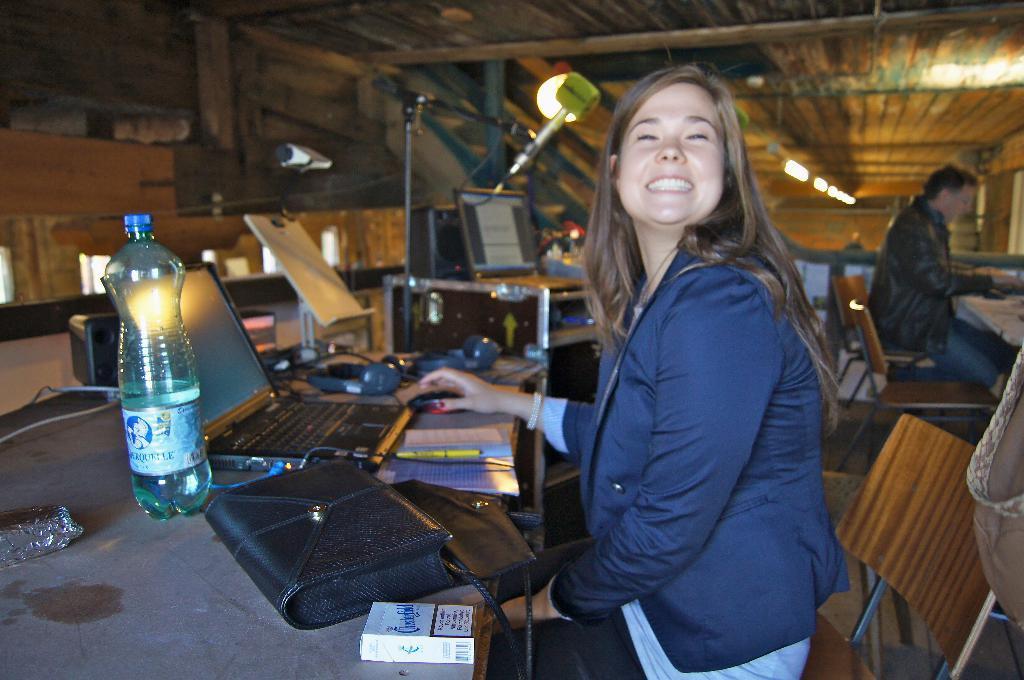Describe this image in one or two sentences. In this image in the center there is one woman who is sitting and smiling in front of her there is one table. On the table there is one hand bag bottle laptop, papers, pen, and two headsets are there and on the background there is a wooden wall beside her there is another table and on that table there is one computer and one light is there and on the right side there is one man who is sitting on a chair. 